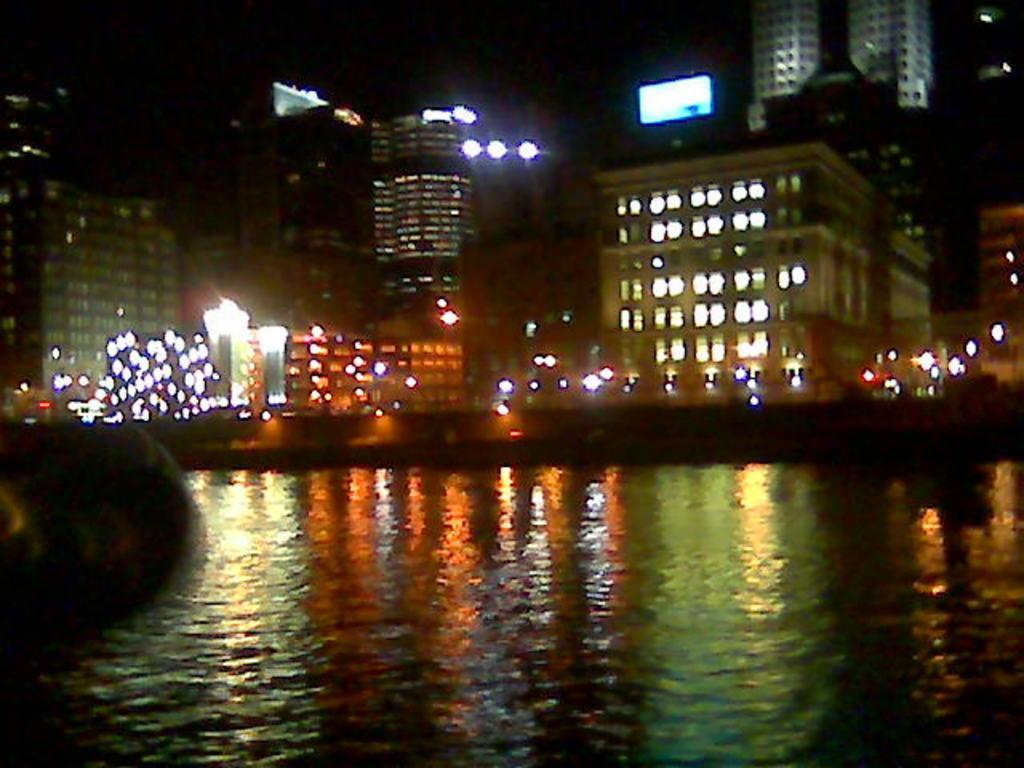Can you describe this image briefly? In this image in the center there is water. In the background there are buildings and there are lights. 